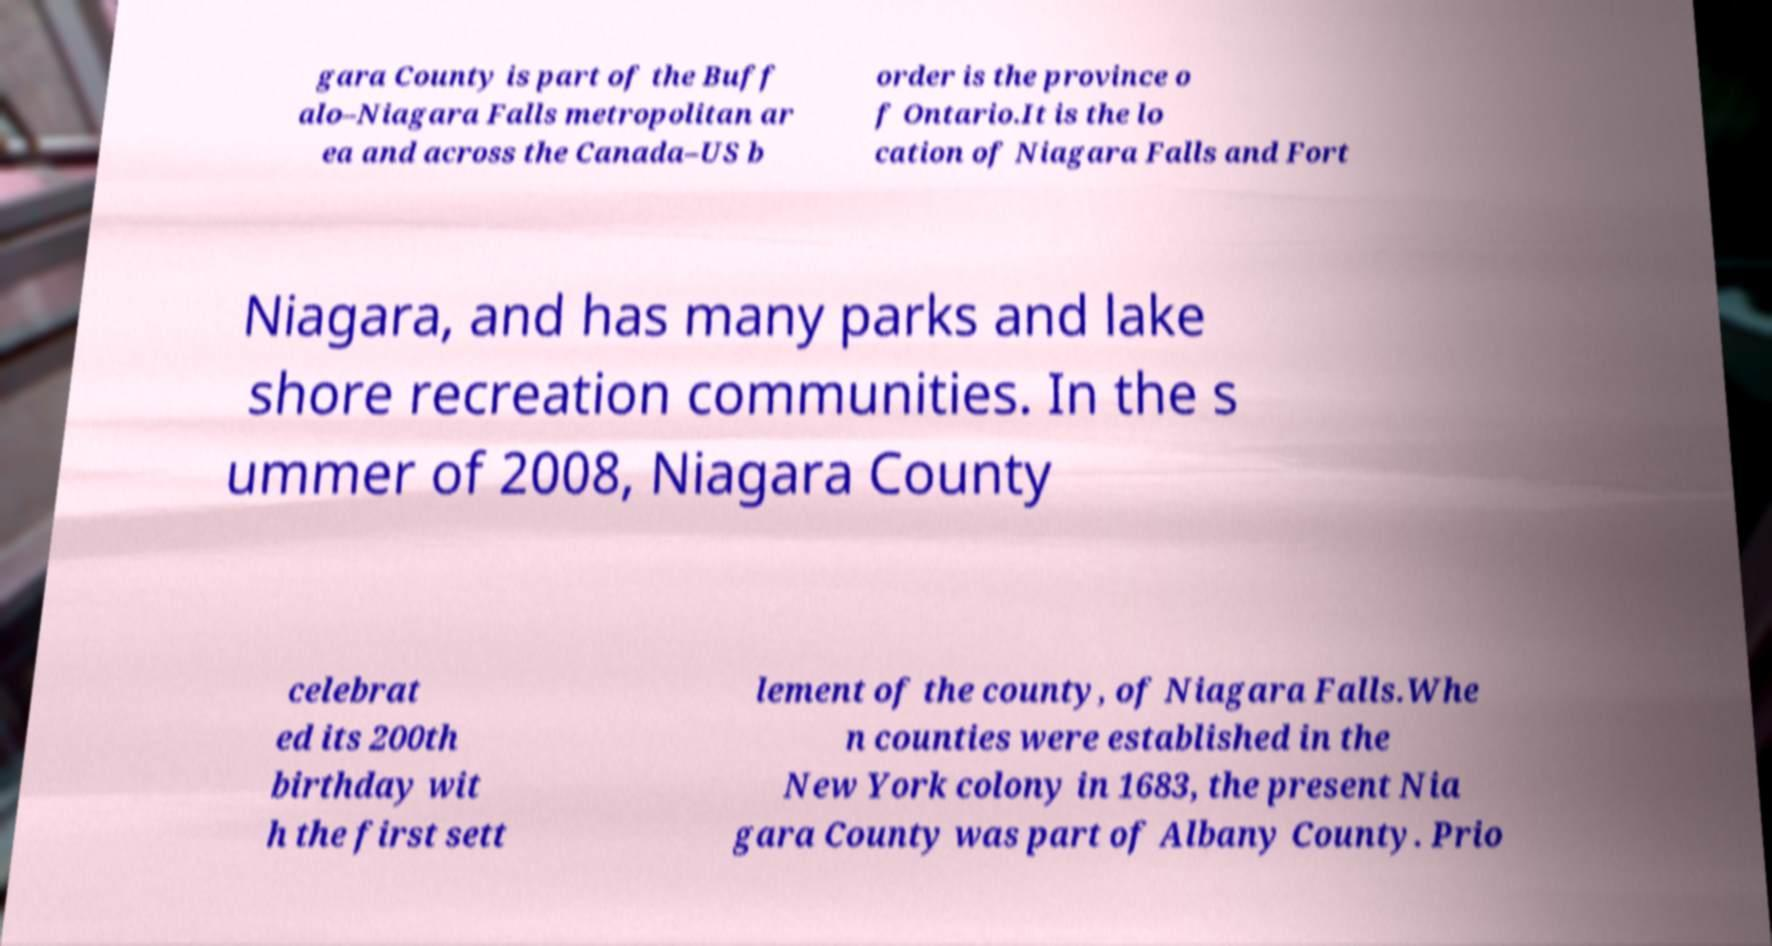Can you read and provide the text displayed in the image?This photo seems to have some interesting text. Can you extract and type it out for me? gara County is part of the Buff alo–Niagara Falls metropolitan ar ea and across the Canada–US b order is the province o f Ontario.It is the lo cation of Niagara Falls and Fort Niagara, and has many parks and lake shore recreation communities. In the s ummer of 2008, Niagara County celebrat ed its 200th birthday wit h the first sett lement of the county, of Niagara Falls.Whe n counties were established in the New York colony in 1683, the present Nia gara County was part of Albany County. Prio 